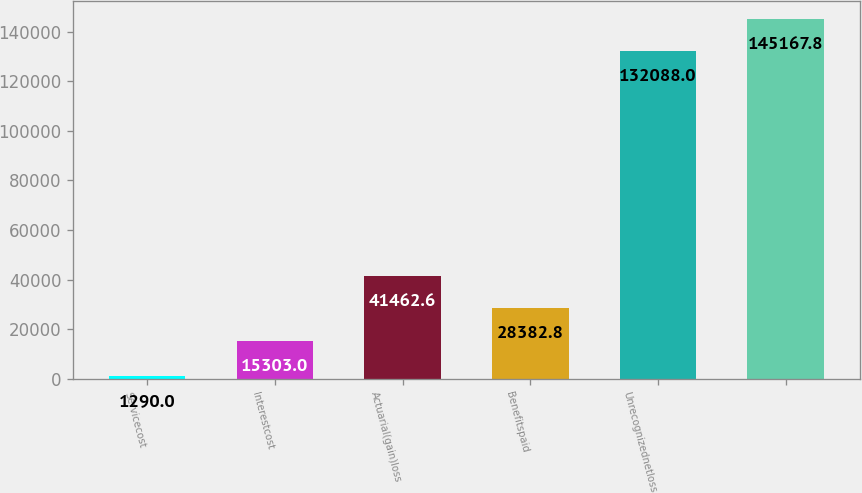Convert chart. <chart><loc_0><loc_0><loc_500><loc_500><bar_chart><fcel>Servicecost<fcel>Interestcost<fcel>Actuarial(gain)loss<fcel>Benefitspaid<fcel>Unrecognizednetloss<fcel>Unnamed: 5<nl><fcel>1290<fcel>15303<fcel>41462.6<fcel>28382.8<fcel>132088<fcel>145168<nl></chart> 